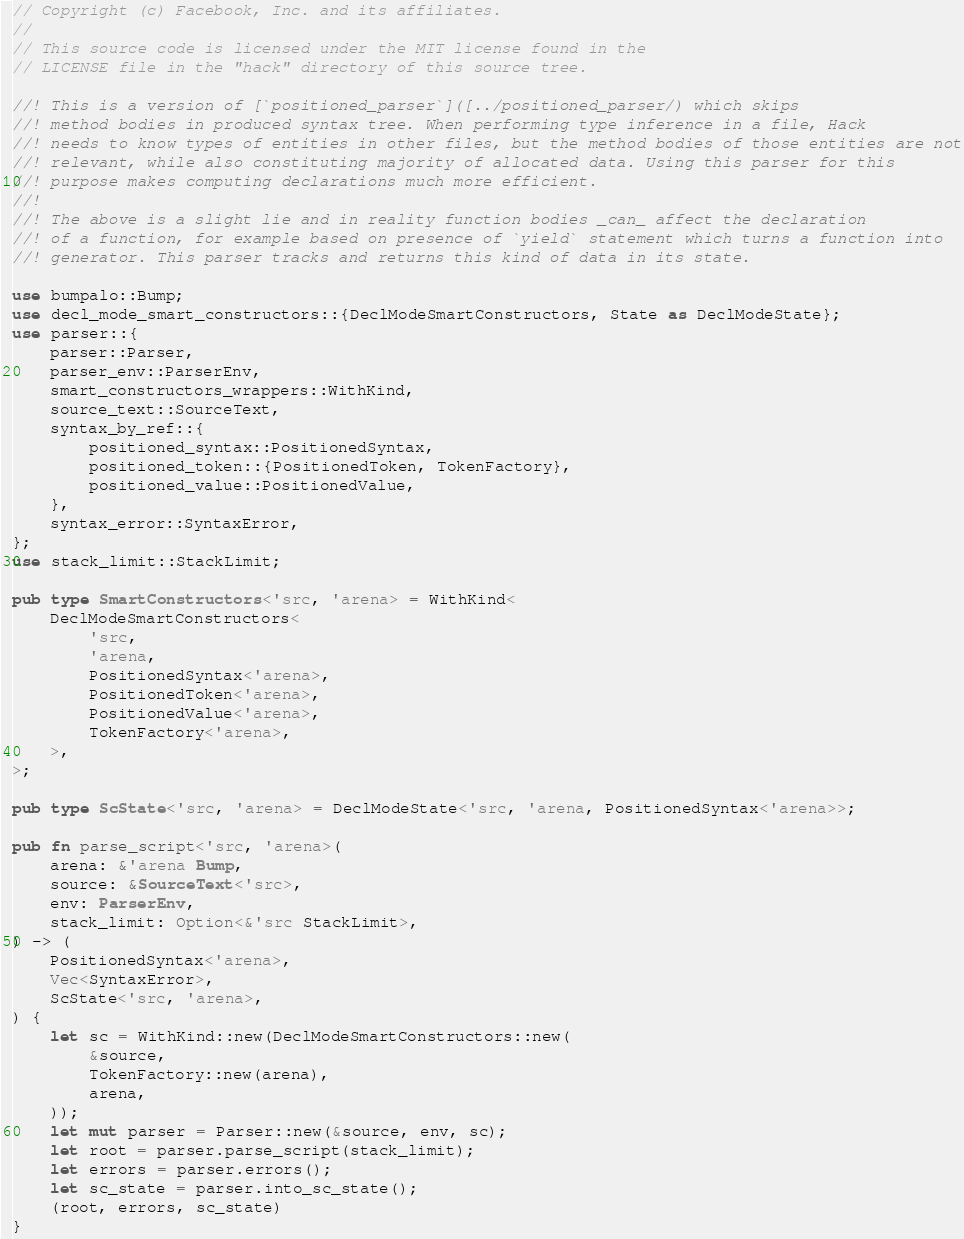Convert code to text. <code><loc_0><loc_0><loc_500><loc_500><_Rust_>// Copyright (c) Facebook, Inc. and its affiliates.
//
// This source code is licensed under the MIT license found in the
// LICENSE file in the "hack" directory of this source tree.

//! This is a version of [`positioned_parser`]([../positioned_parser/) which skips
//! method bodies in produced syntax tree. When performing type inference in a file, Hack
//! needs to know types of entities in other files, but the method bodies of those entities are not
//! relevant, while also constituting majority of allocated data. Using this parser for this
//! purpose makes computing declarations much more efficient.
//!
//! The above is a slight lie and in reality function bodies _can_ affect the declaration
//! of a function, for example based on presence of `yield` statement which turns a function into
//! generator. This parser tracks and returns this kind of data in its state.

use bumpalo::Bump;
use decl_mode_smart_constructors::{DeclModeSmartConstructors, State as DeclModeState};
use parser::{
    parser::Parser,
    parser_env::ParserEnv,
    smart_constructors_wrappers::WithKind,
    source_text::SourceText,
    syntax_by_ref::{
        positioned_syntax::PositionedSyntax,
        positioned_token::{PositionedToken, TokenFactory},
        positioned_value::PositionedValue,
    },
    syntax_error::SyntaxError,
};
use stack_limit::StackLimit;

pub type SmartConstructors<'src, 'arena> = WithKind<
    DeclModeSmartConstructors<
        'src,
        'arena,
        PositionedSyntax<'arena>,
        PositionedToken<'arena>,
        PositionedValue<'arena>,
        TokenFactory<'arena>,
    >,
>;

pub type ScState<'src, 'arena> = DeclModeState<'src, 'arena, PositionedSyntax<'arena>>;

pub fn parse_script<'src, 'arena>(
    arena: &'arena Bump,
    source: &SourceText<'src>,
    env: ParserEnv,
    stack_limit: Option<&'src StackLimit>,
) -> (
    PositionedSyntax<'arena>,
    Vec<SyntaxError>,
    ScState<'src, 'arena>,
) {
    let sc = WithKind::new(DeclModeSmartConstructors::new(
        &source,
        TokenFactory::new(arena),
        arena,
    ));
    let mut parser = Parser::new(&source, env, sc);
    let root = parser.parse_script(stack_limit);
    let errors = parser.errors();
    let sc_state = parser.into_sc_state();
    (root, errors, sc_state)
}
</code> 